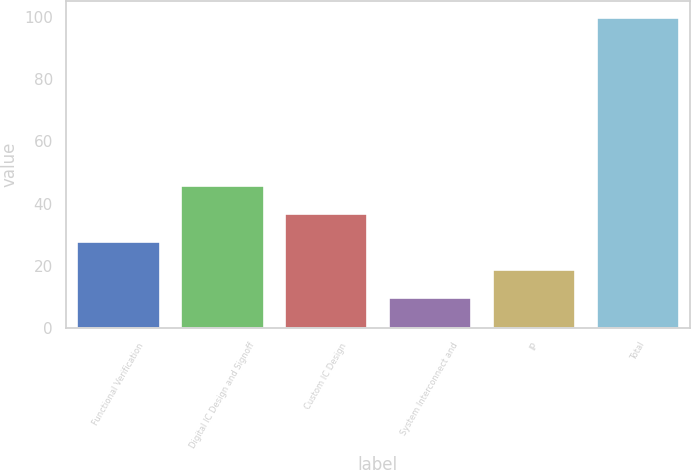<chart> <loc_0><loc_0><loc_500><loc_500><bar_chart><fcel>Functional Verification<fcel>Digital IC Design and Signoff<fcel>Custom IC Design<fcel>System Interconnect and<fcel>IP<fcel>Total<nl><fcel>28<fcel>46<fcel>37<fcel>10<fcel>19<fcel>100<nl></chart> 